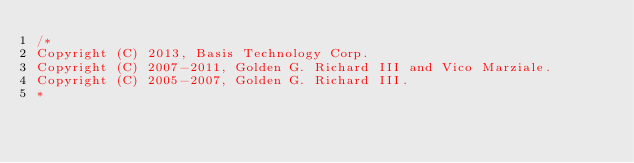<code> <loc_0><loc_0><loc_500><loc_500><_C++_>/*
Copyright (C) 2013, Basis Technology Corp.
Copyright (C) 2007-2011, Golden G. Richard III and Vico Marziale.
Copyright (C) 2005-2007, Golden G. Richard III.
*</code> 